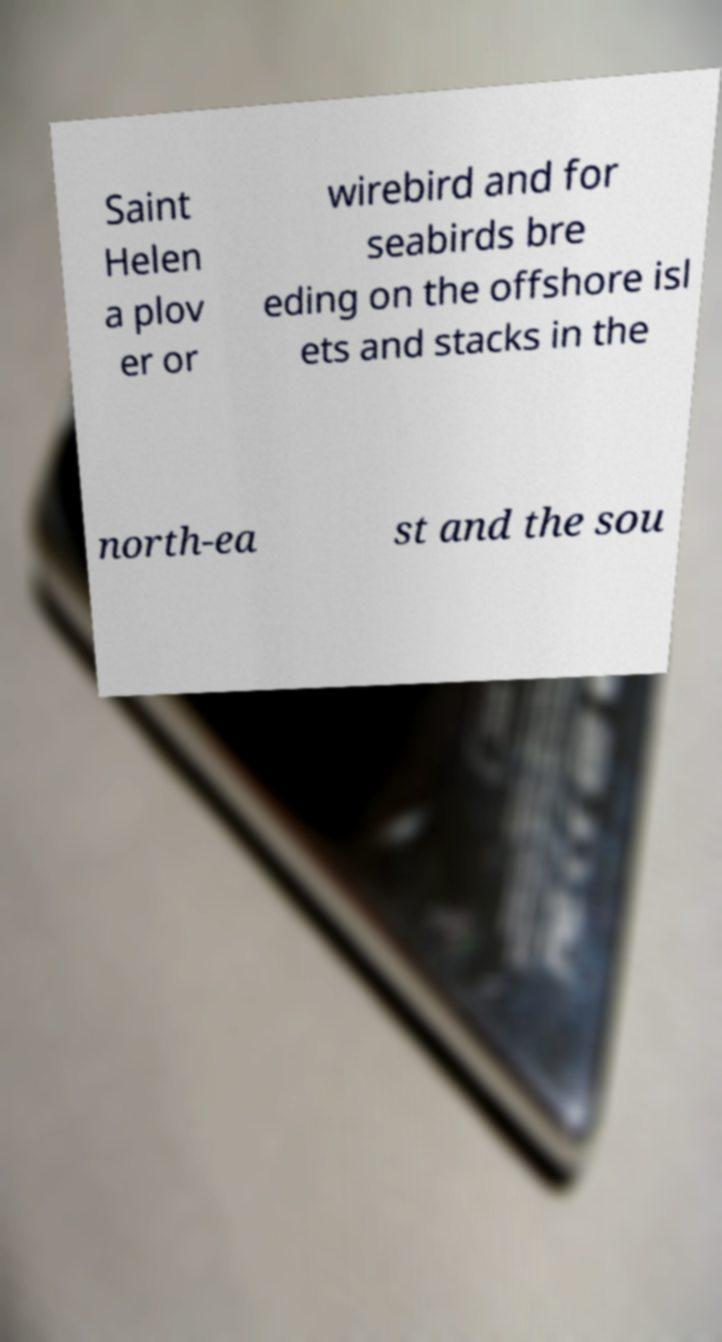Can you accurately transcribe the text from the provided image for me? Saint Helen a plov er or wirebird and for seabirds bre eding on the offshore isl ets and stacks in the north-ea st and the sou 